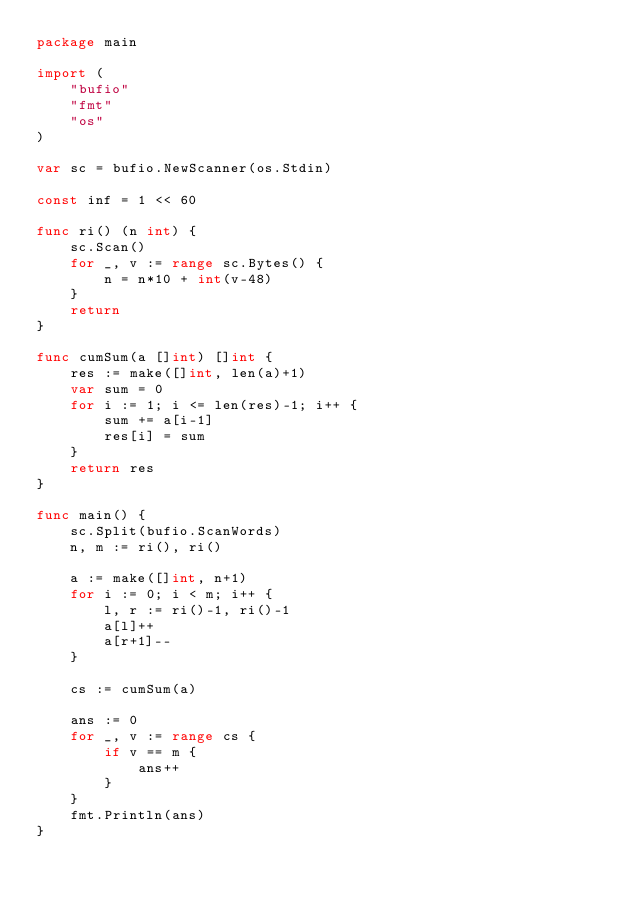Convert code to text. <code><loc_0><loc_0><loc_500><loc_500><_Go_>package main

import (
	"bufio"
	"fmt"
	"os"
)

var sc = bufio.NewScanner(os.Stdin)

const inf = 1 << 60

func ri() (n int) {
	sc.Scan()
	for _, v := range sc.Bytes() {
		n = n*10 + int(v-48)
	}
	return
}

func cumSum(a []int) []int {
	res := make([]int, len(a)+1)
	var sum = 0
	for i := 1; i <= len(res)-1; i++ {
		sum += a[i-1]
		res[i] = sum
	}
	return res
}

func main() {
	sc.Split(bufio.ScanWords)
	n, m := ri(), ri()

	a := make([]int, n+1)
	for i := 0; i < m; i++ {
		l, r := ri()-1, ri()-1
		a[l]++
		a[r+1]--
	}

	cs := cumSum(a)

	ans := 0
	for _, v := range cs {
		if v == m {
			ans++
		}
	}
	fmt.Println(ans)
}
</code> 